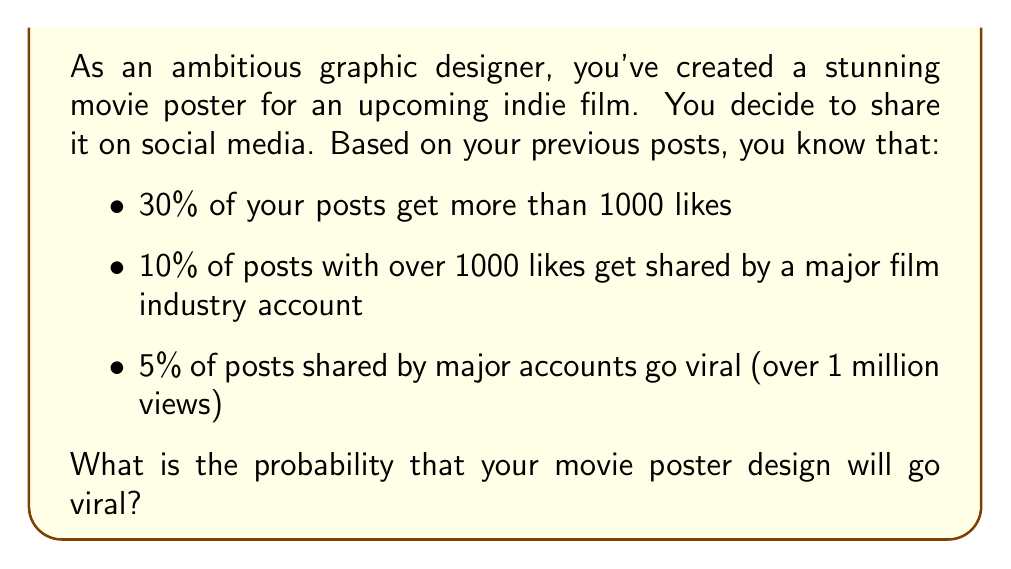Teach me how to tackle this problem. Let's break this down step-by-step:

1) First, we need to identify the chain of events that lead to a post going viral:
   - The post must get more than 1000 likes
   - It must then be shared by a major film industry account
   - Finally, it must go viral after being shared

2) We can calculate this using the multiplication rule of probability, as each event is dependent on the previous one occurring:

   $P(\text{viral}) = P(\text{>1000 likes}) \times P(\text{shared|>1000 likes}) \times P(\text{viral|shared})$

3) Let's plug in the given probabilities:
   
   $P(\text{viral}) = 0.30 \times 0.10 \times 0.05$

4) Now we can calculate:
   
   $P(\text{viral}) = 0.30 \times 0.10 \times 0.05 = 0.0015$

5) To convert to a percentage, we multiply by 100:
   
   $0.0015 \times 100 = 0.15\%$

Therefore, there is a 0.15% chance that your movie poster design will go viral.
Answer: 0.15% 